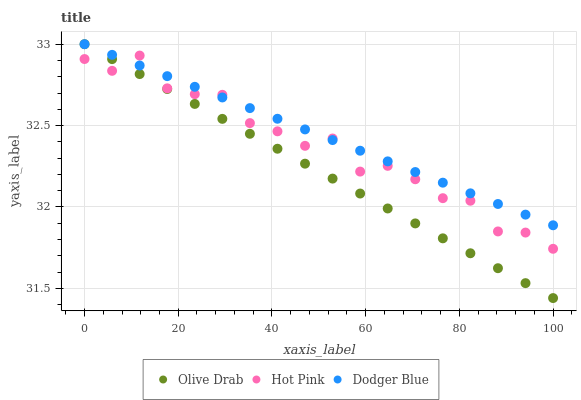Does Olive Drab have the minimum area under the curve?
Answer yes or no. Yes. Does Dodger Blue have the maximum area under the curve?
Answer yes or no. Yes. Does Dodger Blue have the minimum area under the curve?
Answer yes or no. No. Does Olive Drab have the maximum area under the curve?
Answer yes or no. No. Is Dodger Blue the smoothest?
Answer yes or no. Yes. Is Hot Pink the roughest?
Answer yes or no. Yes. Is Olive Drab the smoothest?
Answer yes or no. No. Is Olive Drab the roughest?
Answer yes or no. No. Does Olive Drab have the lowest value?
Answer yes or no. Yes. Does Dodger Blue have the lowest value?
Answer yes or no. No. Does Olive Drab have the highest value?
Answer yes or no. Yes. Does Dodger Blue intersect Olive Drab?
Answer yes or no. Yes. Is Dodger Blue less than Olive Drab?
Answer yes or no. No. Is Dodger Blue greater than Olive Drab?
Answer yes or no. No. 